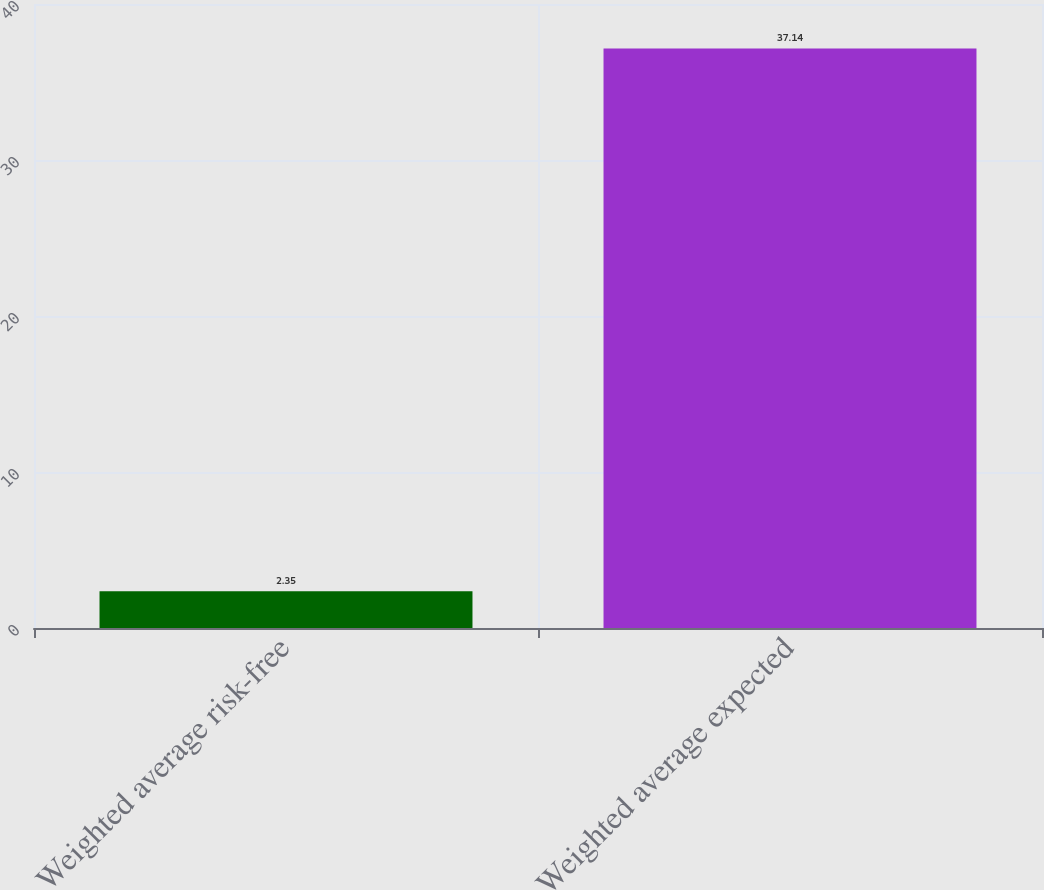Convert chart to OTSL. <chart><loc_0><loc_0><loc_500><loc_500><bar_chart><fcel>Weighted average risk-free<fcel>Weighted average expected<nl><fcel>2.35<fcel>37.14<nl></chart> 